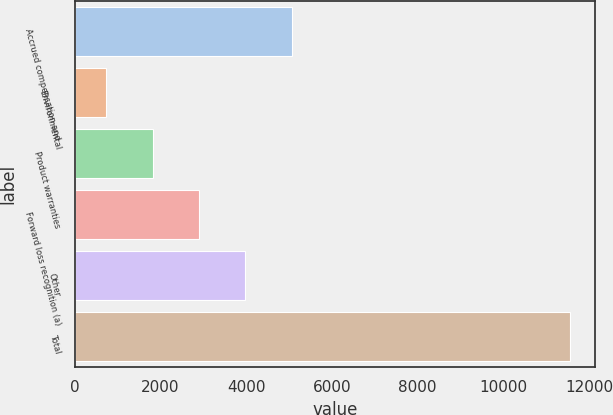<chart> <loc_0><loc_0><loc_500><loc_500><bar_chart><fcel>Accrued compensation and<fcel>Environmental<fcel>Product warranties<fcel>Forward loss recognition (a)<fcel>Other<fcel>Total<nl><fcel>5064.2<fcel>731<fcel>1814.3<fcel>2897.6<fcel>3980.9<fcel>11564<nl></chart> 